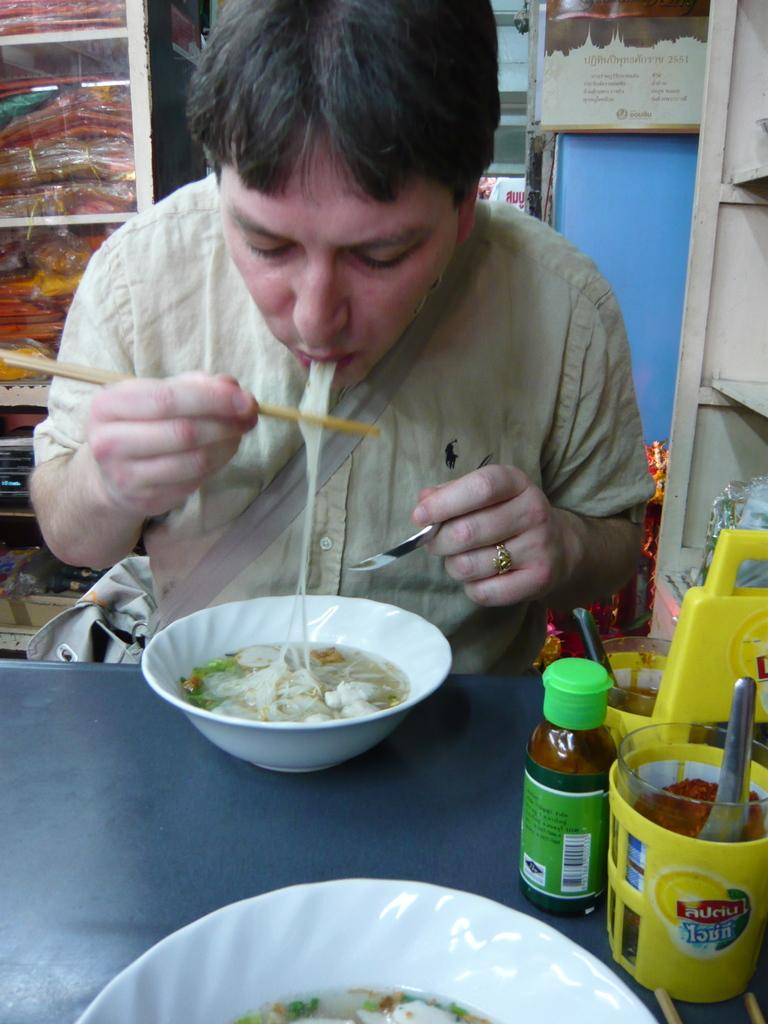<image>
Present a compact description of the photo's key features. A man is eating noodles next to a yellow auciu jar. 